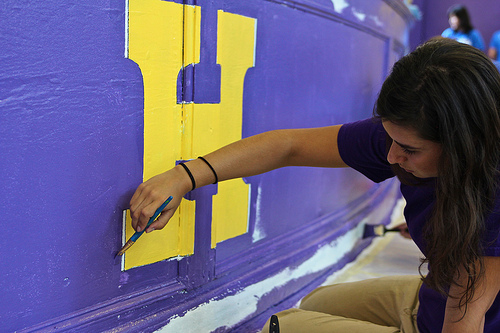<image>
Is there a letter h on the wall? Yes. Looking at the image, I can see the letter h is positioned on top of the wall, with the wall providing support. Is there a woman in front of the letter h? Yes. The woman is positioned in front of the letter h, appearing closer to the camera viewpoint. 